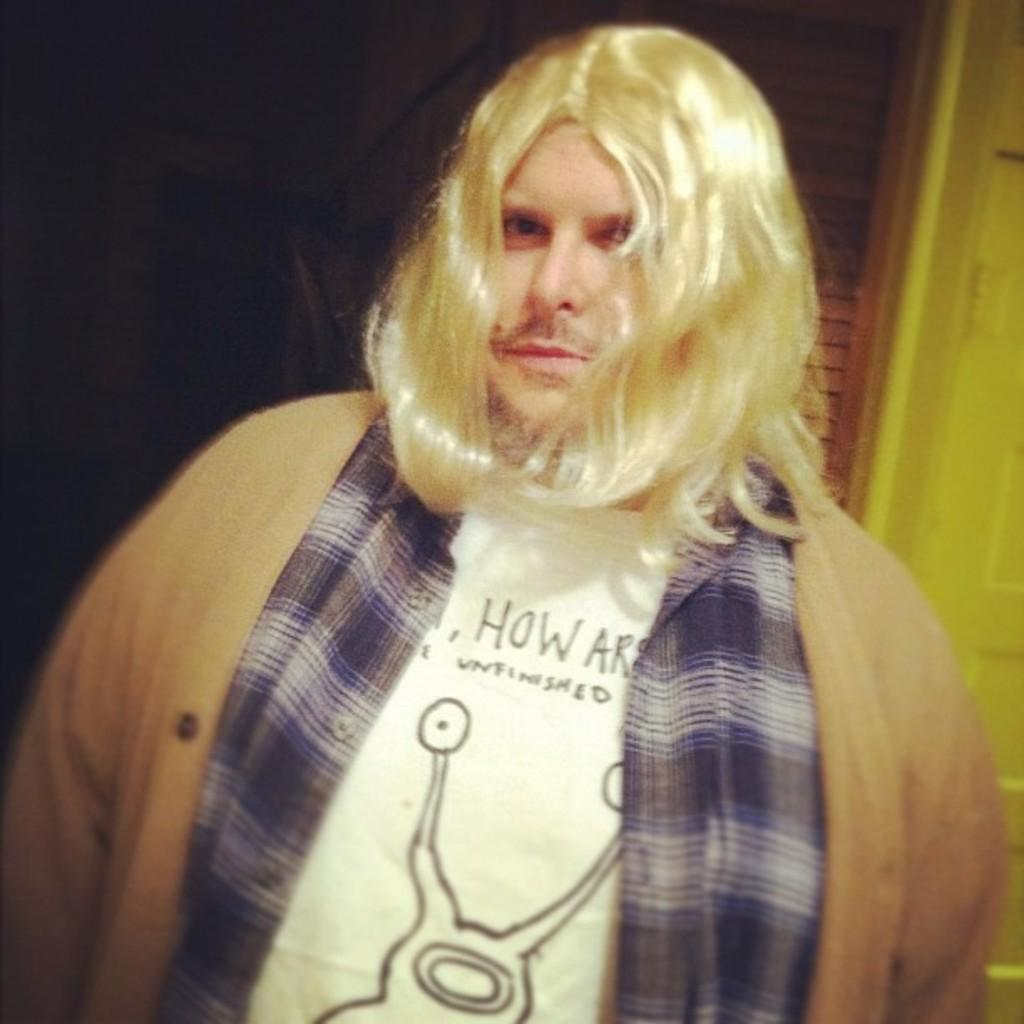Who is present in the image? There is a man in the image. What can be seen in the background of the image? The background of the image is dark on the left side. What is the object in the image? There is an object in the image, which is a wooden object. What type of structure can be seen in the image? There is a door in the image. What type of brush is the beggar using to clean the cheese in the image? There is no brush, beggar, or cheese present in the image. 